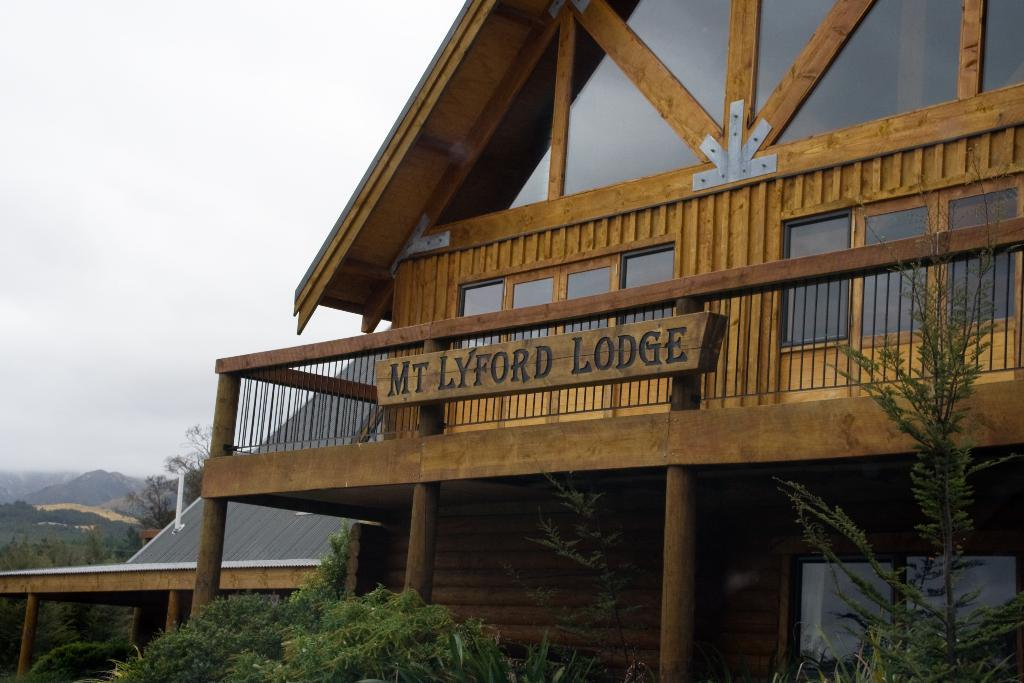What type of natural elements can be seen in the image? There are trees and mountains in the image. What architectural features are present in the image? There are pillars and buildings with windows in the image. What is the purpose of the name board in the image? The name board in the image likely indicates the name or purpose of a building or location. What can be seen in the background of the image? The sky with clouds is visible in the background of the image. How does the wax melt in the image? There is no wax present in the image. What type of muscle can be seen flexing in the image? There are no muscles or people flexing in the image. 